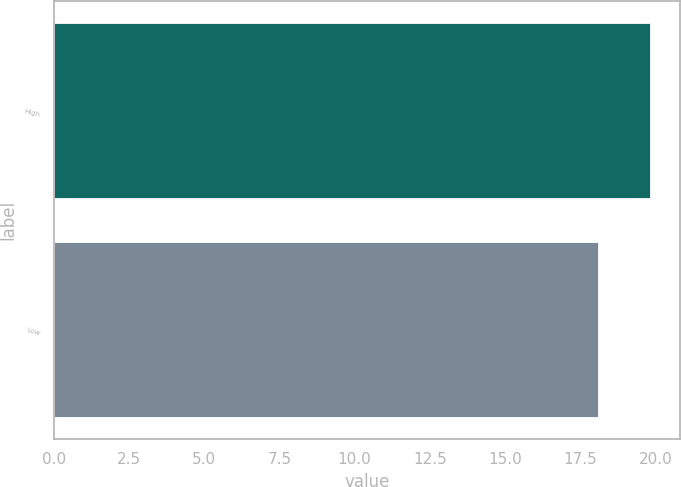Convert chart. <chart><loc_0><loc_0><loc_500><loc_500><bar_chart><fcel>High<fcel>Low<nl><fcel>19.82<fcel>18.08<nl></chart> 